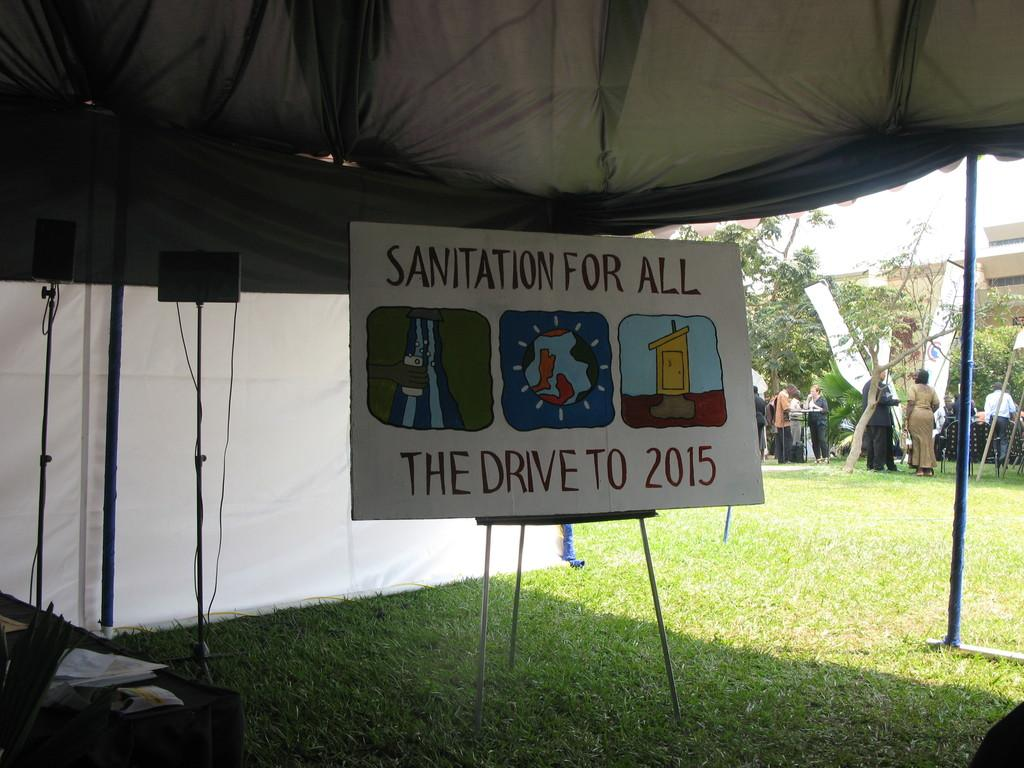What is under the tent in the image? There is a board under the tent in the image. What is the terrain like in the image? The land is covered with grass. What can be seen in the background of the image? There are trees and a building in the background of the image. Are there any people visible in the image? Yes, there are persons in the background of the image. What type of cloth is draped over the tent in the image? There is no cloth draped over the tent in the image; it is placed on a board. How many tickets are visible in the image? There are no tickets present in the image. 